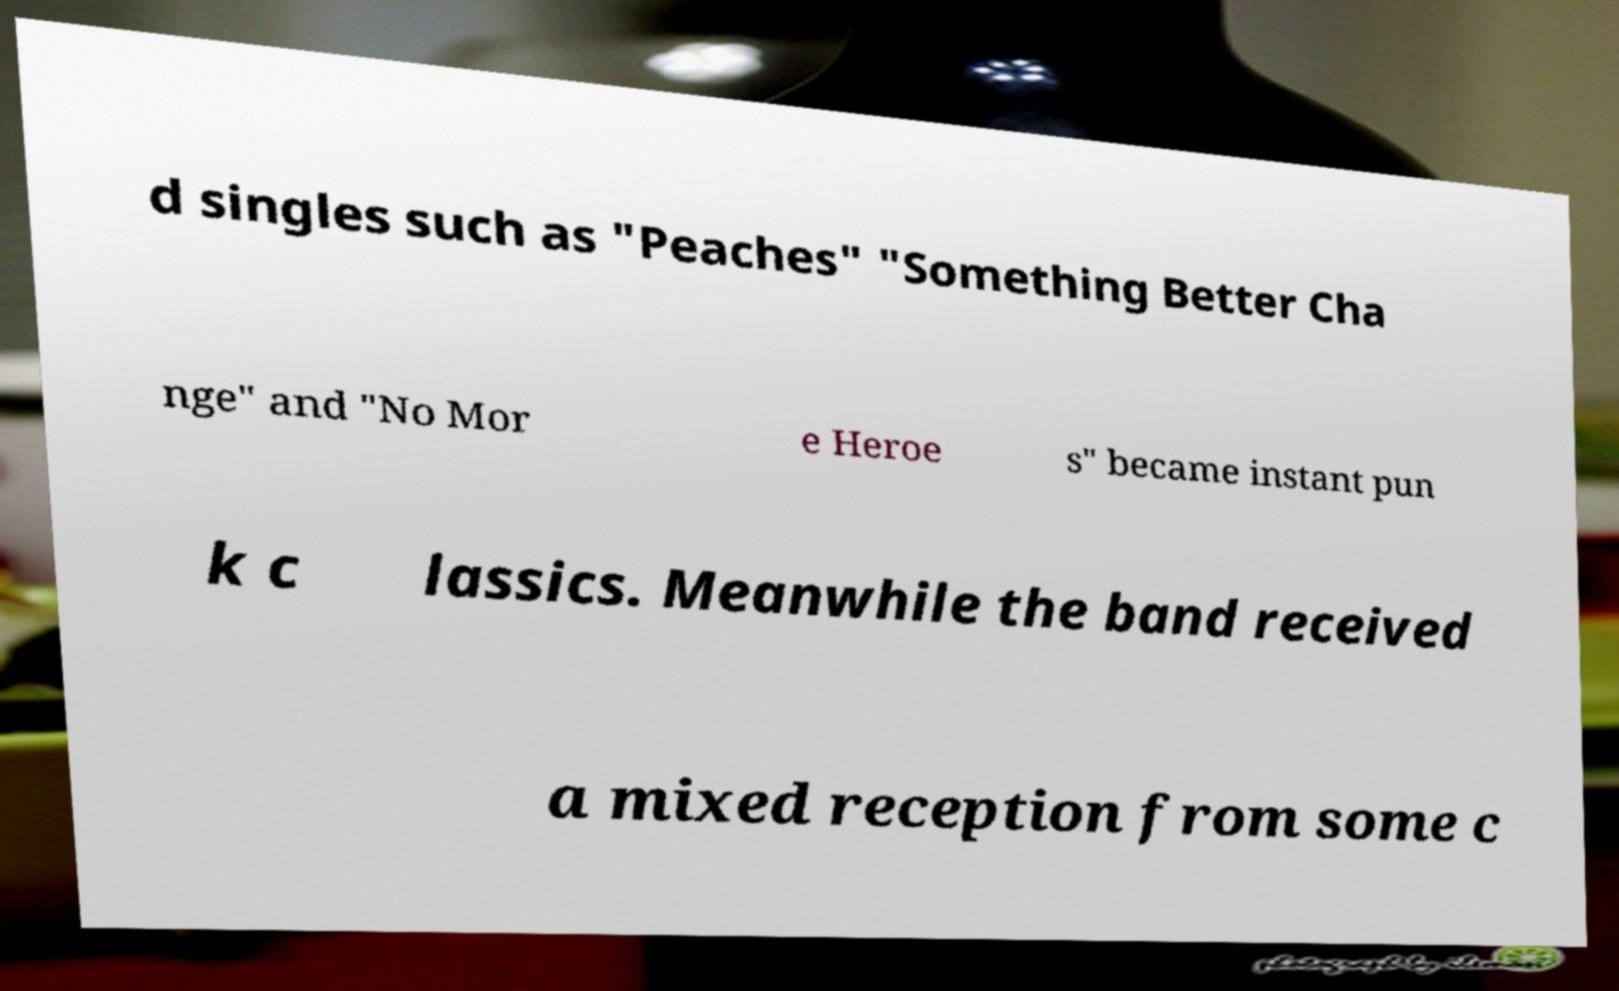Please read and relay the text visible in this image. What does it say? d singles such as "Peaches" "Something Better Cha nge" and "No Mor e Heroe s" became instant pun k c lassics. Meanwhile the band received a mixed reception from some c 